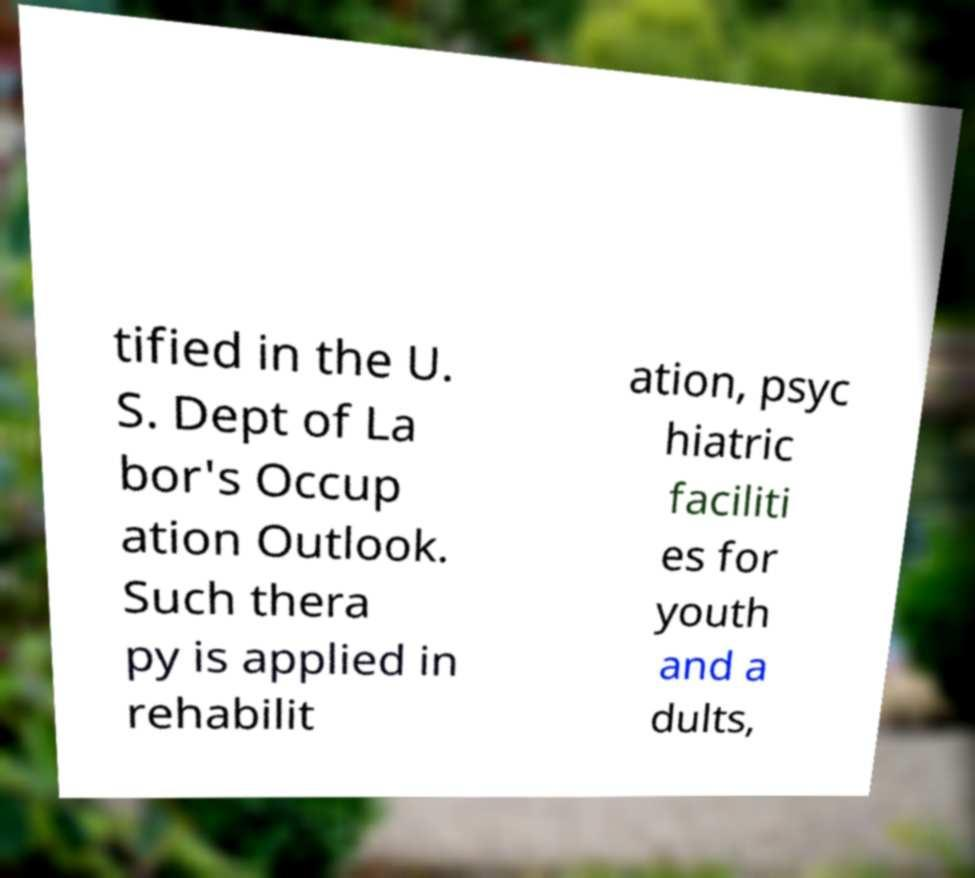There's text embedded in this image that I need extracted. Can you transcribe it verbatim? tified in the U. S. Dept of La bor's Occup ation Outlook. Such thera py is applied in rehabilit ation, psyc hiatric faciliti es for youth and a dults, 